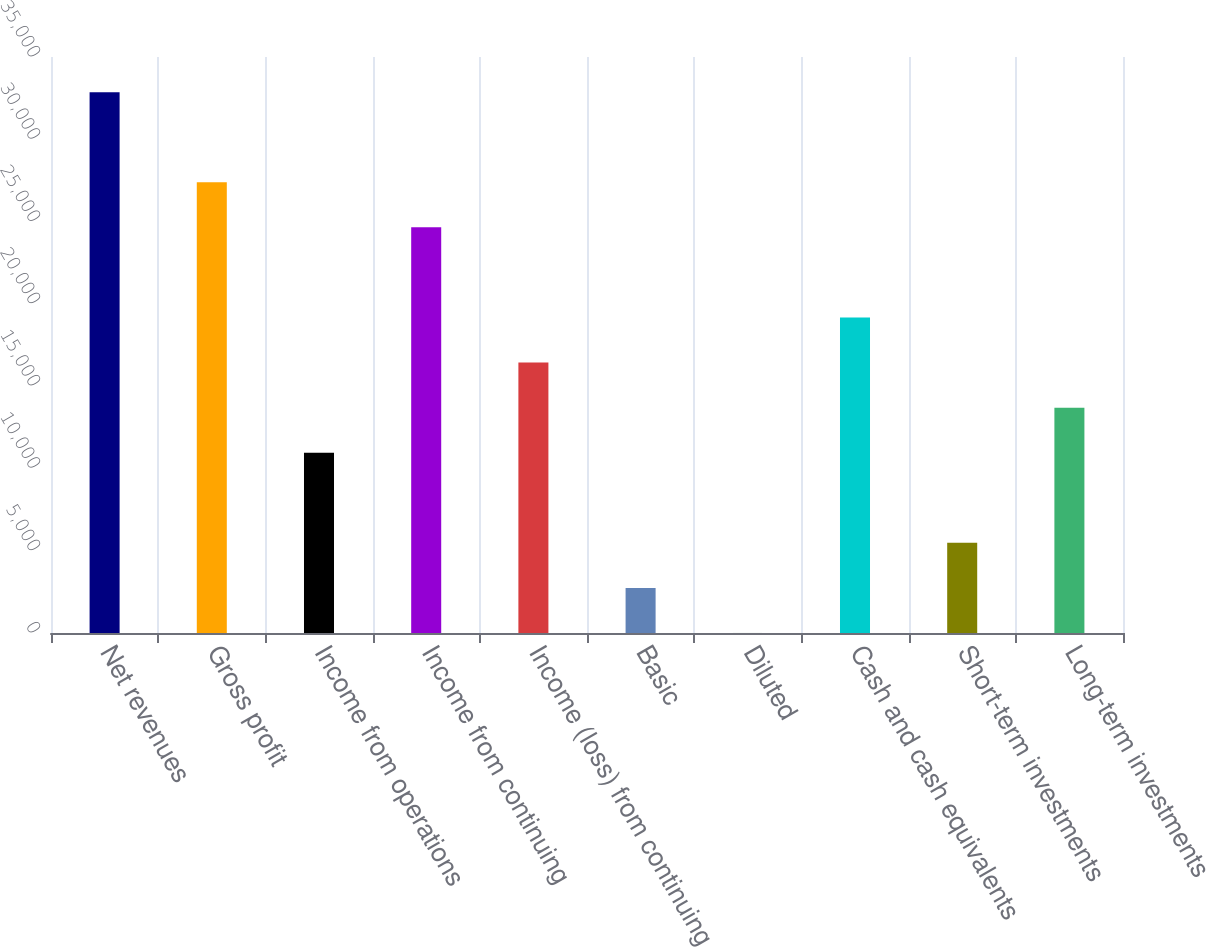<chart> <loc_0><loc_0><loc_500><loc_500><bar_chart><fcel>Net revenues<fcel>Gross profit<fcel>Income from operations<fcel>Income from continuing<fcel>Income (loss) from continuing<fcel>Basic<fcel>Diluted<fcel>Cash and cash equivalents<fcel>Short-term investments<fcel>Long-term investments<nl><fcel>32862.8<fcel>27386<fcel>10955.7<fcel>24647.6<fcel>16432.5<fcel>2740.5<fcel>2.11<fcel>19170.8<fcel>5478.89<fcel>13694.1<nl></chart> 